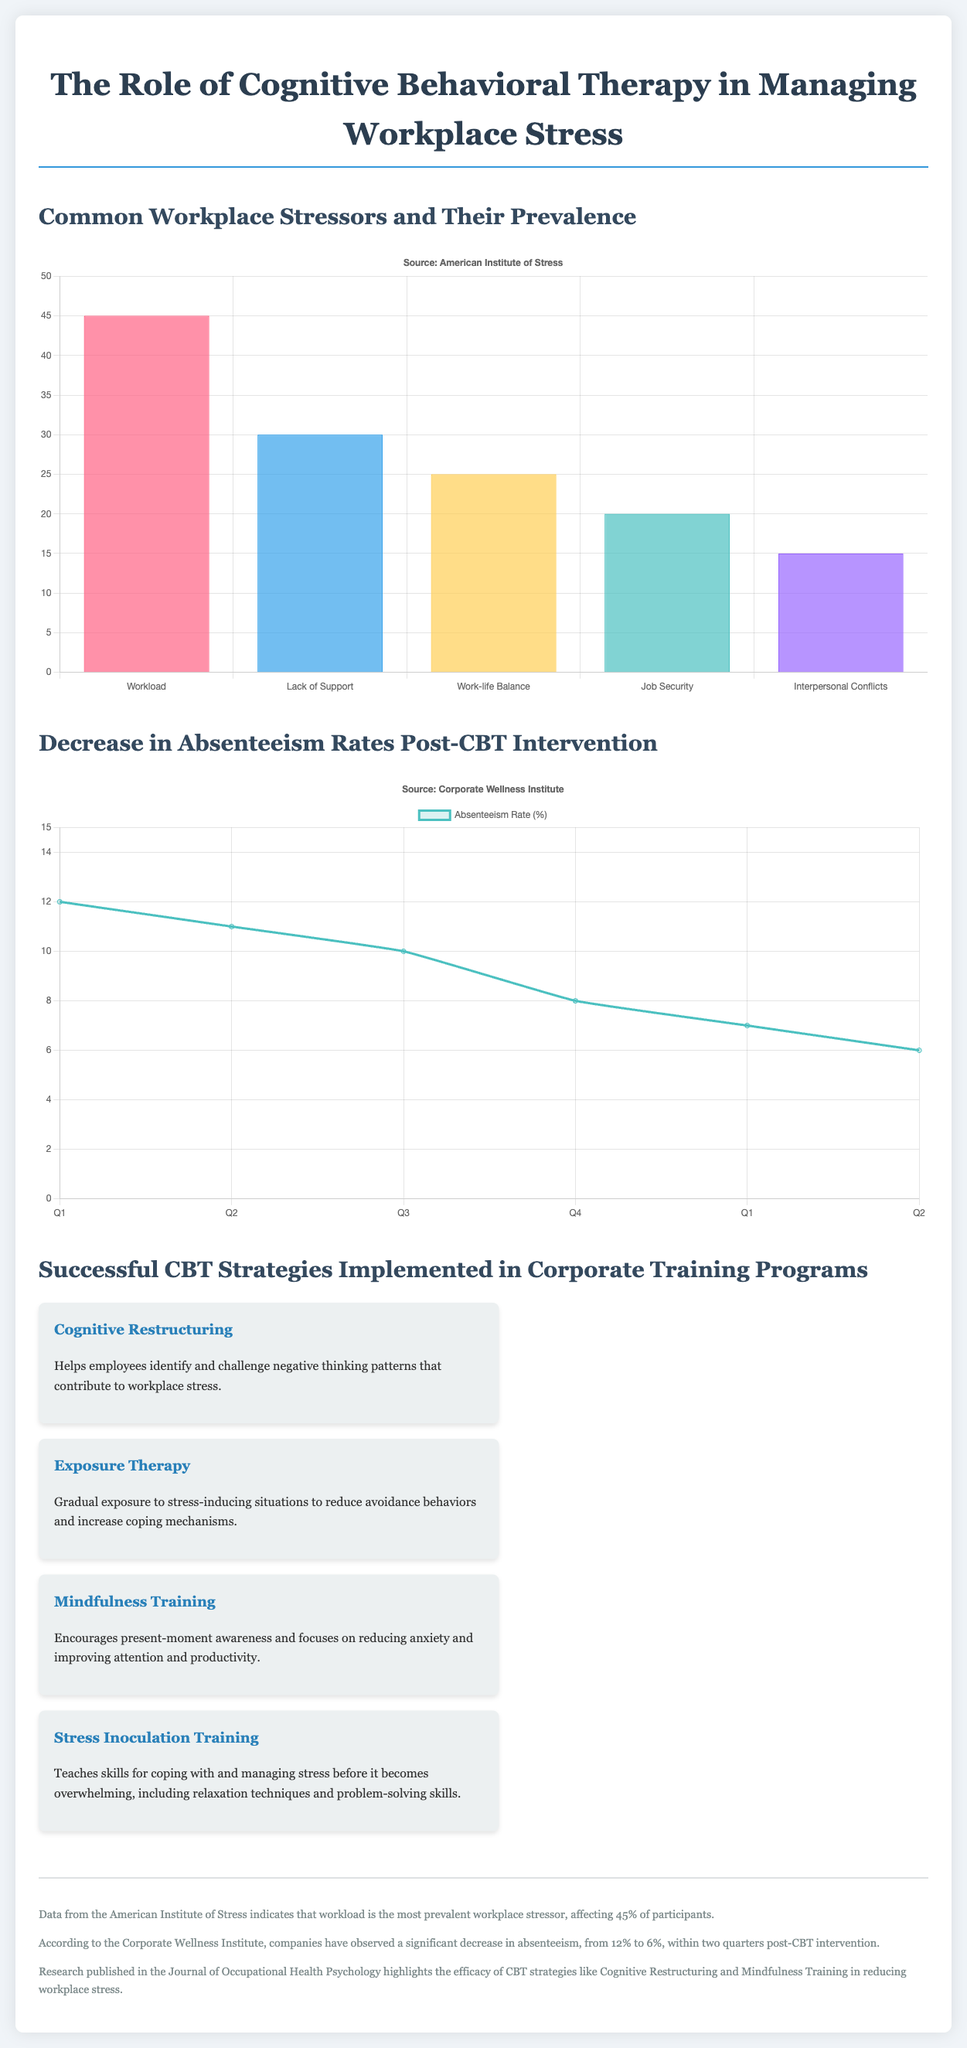What is the most prevalent workplace stressor? The most prevalent workplace stressor is indicated in the bar chart, which shows workload affecting 45% of participants.
Answer: Workload What percentage of participants experience a lack of support as a workplace stressor? This percentage is shown in the bar chart related to workplace stressors, which indicates 30% for lack of support.
Answer: 30% What was the absenteeism rate in Q1 before the CBT intervention? The absenteeism rate in Q1 is provided in the line chart, showing 12% before the intervention.
Answer: 12% What is the lowest absenteeism rate post-CBT intervention? The lowest absenteeism rate after the intervention is identified in the line chart, which shows 6%.
Answer: 6% Which CBT strategy focuses on present-moment awareness? The infographic specifies this CBT strategy, which is mindfulness training that encourages present-moment awareness.
Answer: Mindfulness Training How many successful CBT strategies are detailed in the infographic? The number of strategies can be counted from the infographic section, showing four successful CBT strategies listed.
Answer: Four What is the range of absenteeism rates before and after the CBT intervention? The range indicates the difference between the rates before and after, specifically from 12% to 6%.
Answer: 12% to 6% What visual format is used to illustrate common workplace stressors? The common workplace stressors are illustrated using a bar chart format.
Answer: Bar Chart What type of chart displays the decrease in absenteeism rates? The document uses a line chart to visualize the decrease in absenteeism rates post-CBT intervention.
Answer: Line Chart 